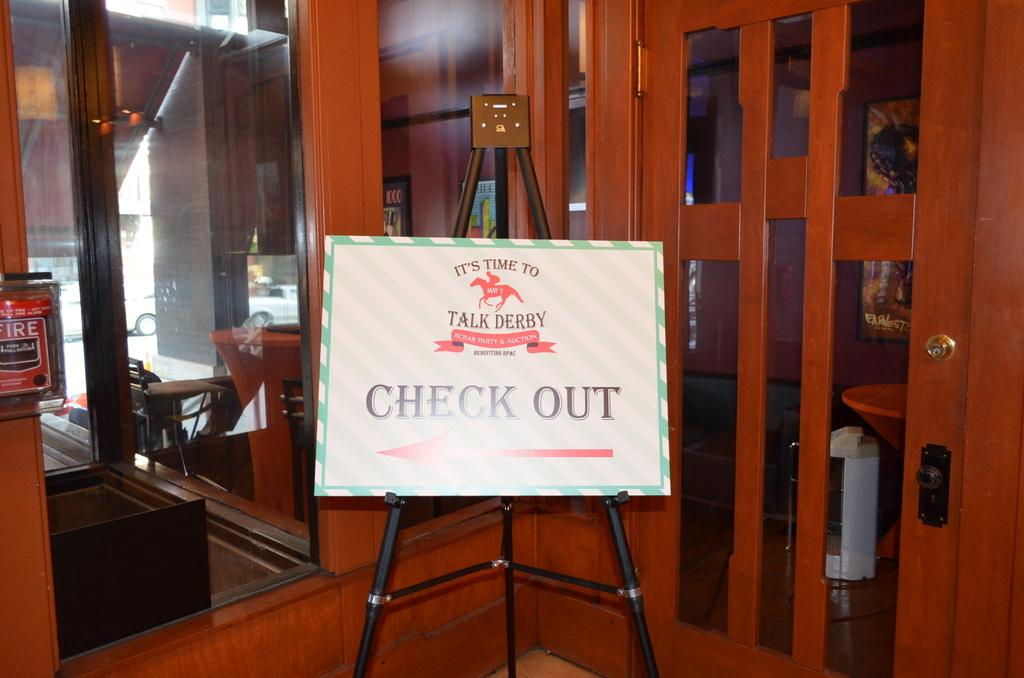What is the main object in the image? There is a board in the image. What can be seen on the right side of the image? There is a door on the right side of the image. What is located on the left side of the image? There is a window on the left side of the image. Can you tell me how many ladybugs are crawling on the board in the image? There are no ladybugs present in the image; it only features a board, a door, and a window. 